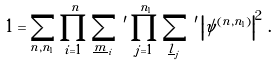<formula> <loc_0><loc_0><loc_500><loc_500>1 = \sum _ { n , n _ { 1 } } \prod _ { i = 1 } ^ { n } \sum _ { \underline { m } _ { i } } \, ^ { \prime } \prod _ { j = 1 } ^ { n _ { 1 } } \sum _ { \underline { l } _ { j } } \, ^ { \prime } \left | \psi ^ { ( n , n _ { 1 } ) } \right | ^ { 2 } \, .</formula> 